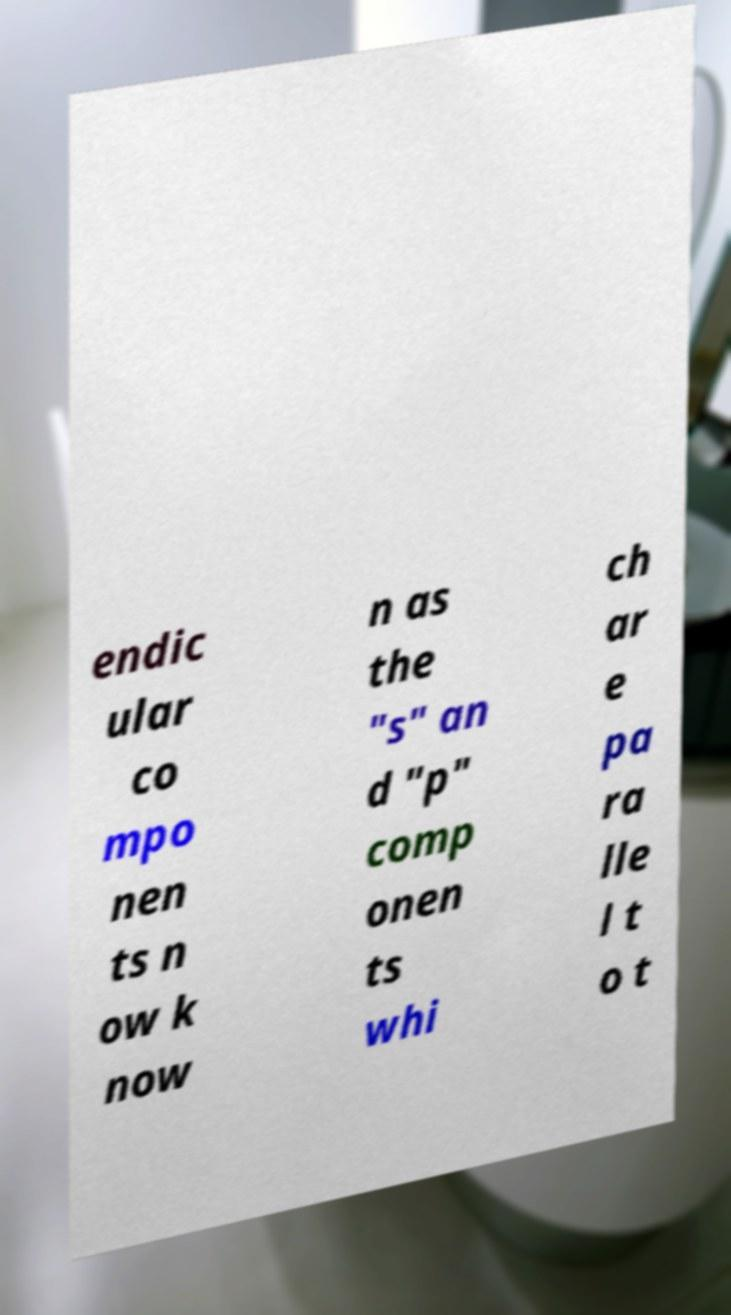I need the written content from this picture converted into text. Can you do that? endic ular co mpo nen ts n ow k now n as the "s" an d "p" comp onen ts whi ch ar e pa ra lle l t o t 